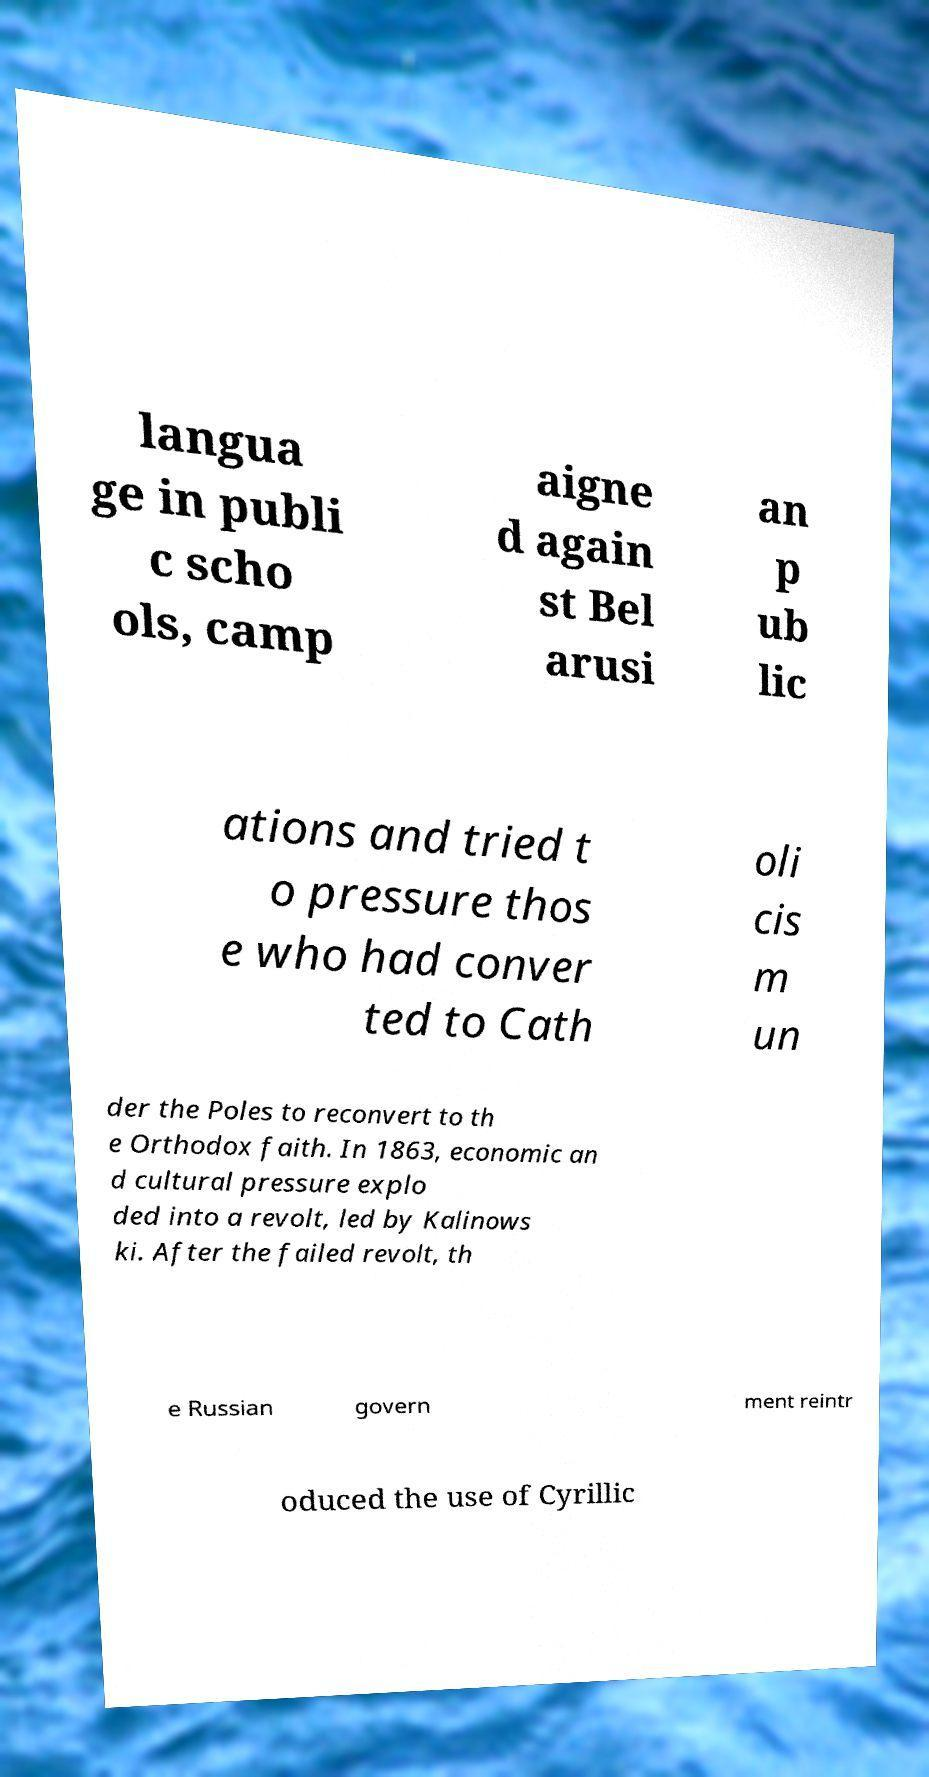Please identify and transcribe the text found in this image. langua ge in publi c scho ols, camp aigne d again st Bel arusi an p ub lic ations and tried t o pressure thos e who had conver ted to Cath oli cis m un der the Poles to reconvert to th e Orthodox faith. In 1863, economic an d cultural pressure explo ded into a revolt, led by Kalinows ki. After the failed revolt, th e Russian govern ment reintr oduced the use of Cyrillic 